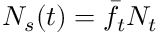Convert formula to latex. <formula><loc_0><loc_0><loc_500><loc_500>N _ { s } ( t ) = \bar { f } _ { t } N _ { t }</formula> 